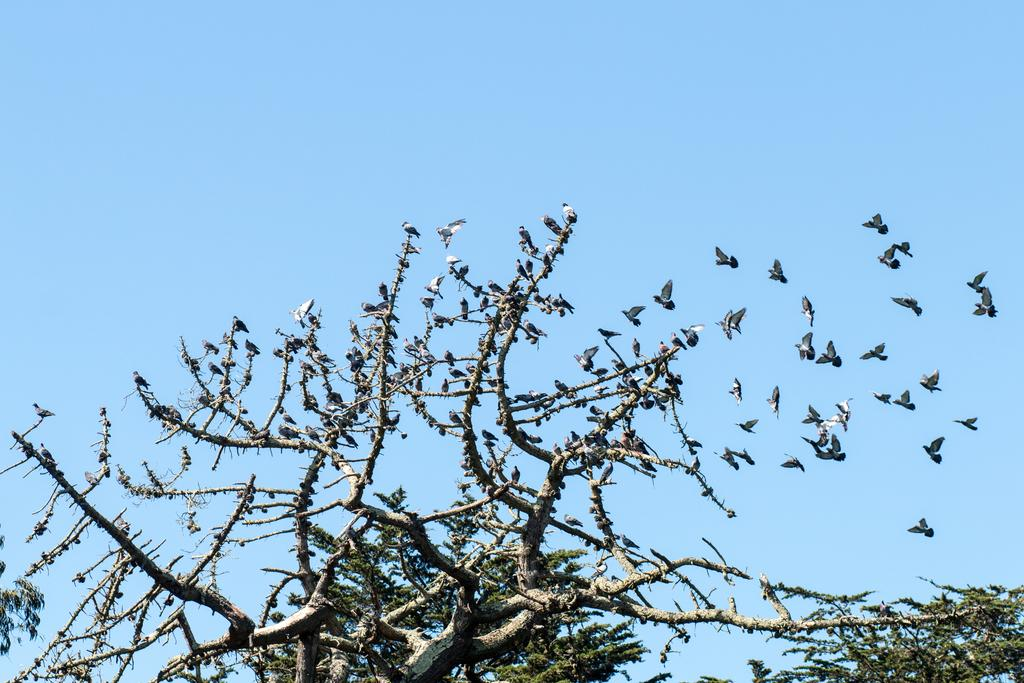What is present on the tree in the image? There are many birds on the tree in the image. What are some of the birds doing in the image? Some of the birds are flying in the image. What can be seen in the background of the image? The sky is visible in the background of the image. What type of impulse can be seen affecting the jail in the image? There is no jail present in the image, and therefore no impulse can be observed affecting it. 